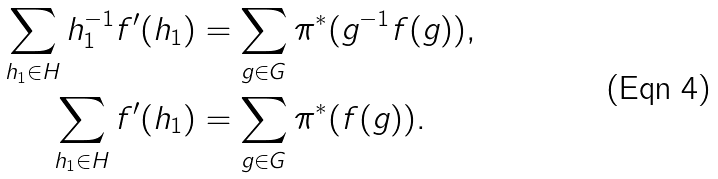Convert formula to latex. <formula><loc_0><loc_0><loc_500><loc_500>\sum _ { h _ { 1 } \in H } h _ { 1 } ^ { - 1 } f ^ { \prime } ( h _ { 1 } ) & = \sum _ { g \in G } \pi ^ { * } ( g ^ { - 1 } f ( g ) ) , \\ \sum _ { h _ { 1 } \in H } f ^ { \prime } ( h _ { 1 } ) & = \sum _ { g \in G } \pi ^ { * } ( f ( g ) ) .</formula> 